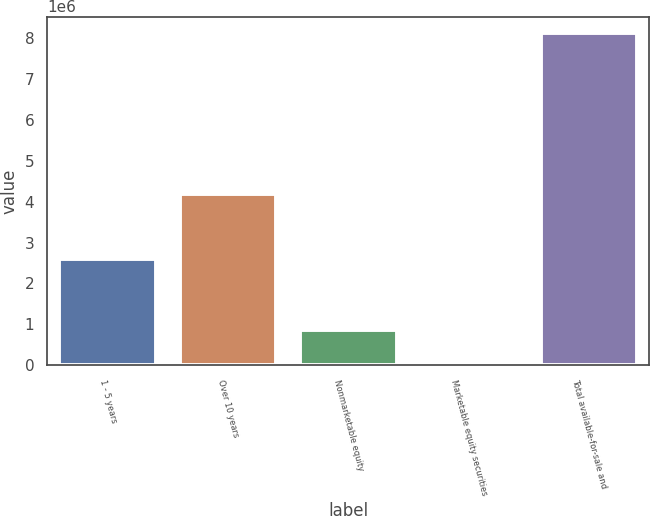<chart> <loc_0><loc_0><loc_500><loc_500><bar_chart><fcel>1 - 5 years<fcel>Over 10 years<fcel>Nonmarketable equity<fcel>Marketable equity securities<fcel>Total available-for-sale and<nl><fcel>2.60866e+06<fcel>4.20105e+06<fcel>860694<fcel>53665<fcel>8.12395e+06<nl></chart> 